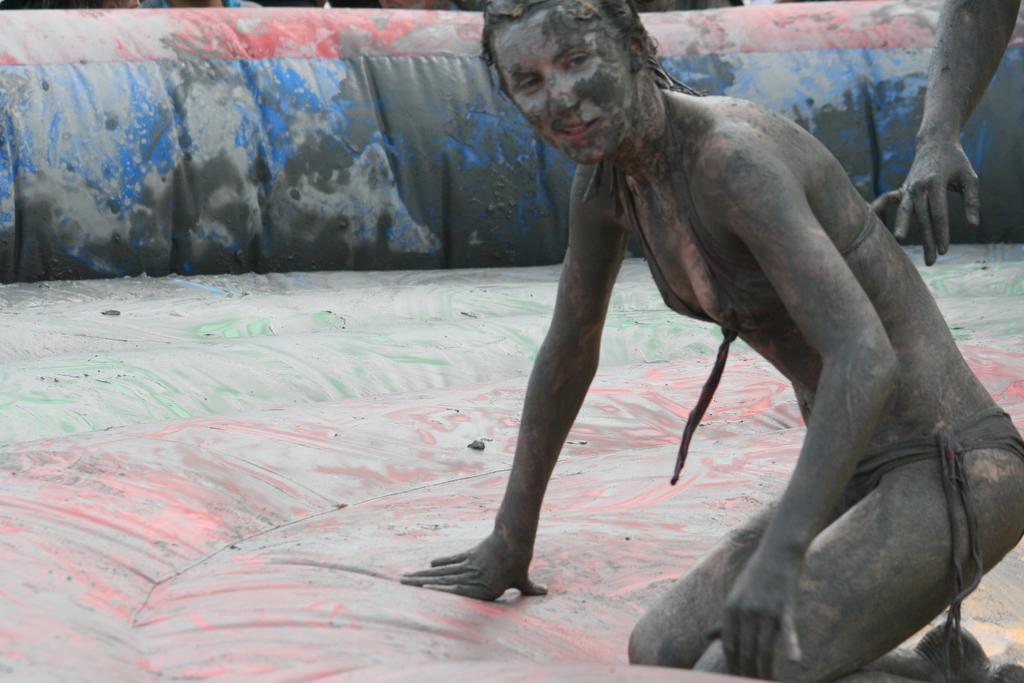Could you give a brief overview of what you see in this image? In this image in the center there is a woman smiling, and on the right side there is the hand of the person which is visible. 